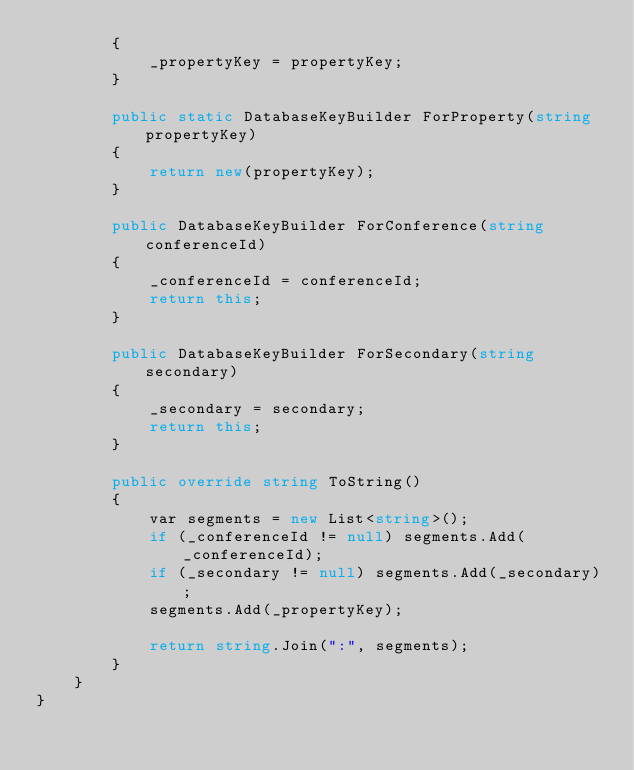<code> <loc_0><loc_0><loc_500><loc_500><_C#_>        {
            _propertyKey = propertyKey;
        }

        public static DatabaseKeyBuilder ForProperty(string propertyKey)
        {
            return new(propertyKey);
        }

        public DatabaseKeyBuilder ForConference(string conferenceId)
        {
            _conferenceId = conferenceId;
            return this;
        }

        public DatabaseKeyBuilder ForSecondary(string secondary)
        {
            _secondary = secondary;
            return this;
        }

        public override string ToString()
        {
            var segments = new List<string>();
            if (_conferenceId != null) segments.Add(_conferenceId);
            if (_secondary != null) segments.Add(_secondary);
            segments.Add(_propertyKey);

            return string.Join(":", segments);
        }
    }
}
</code> 